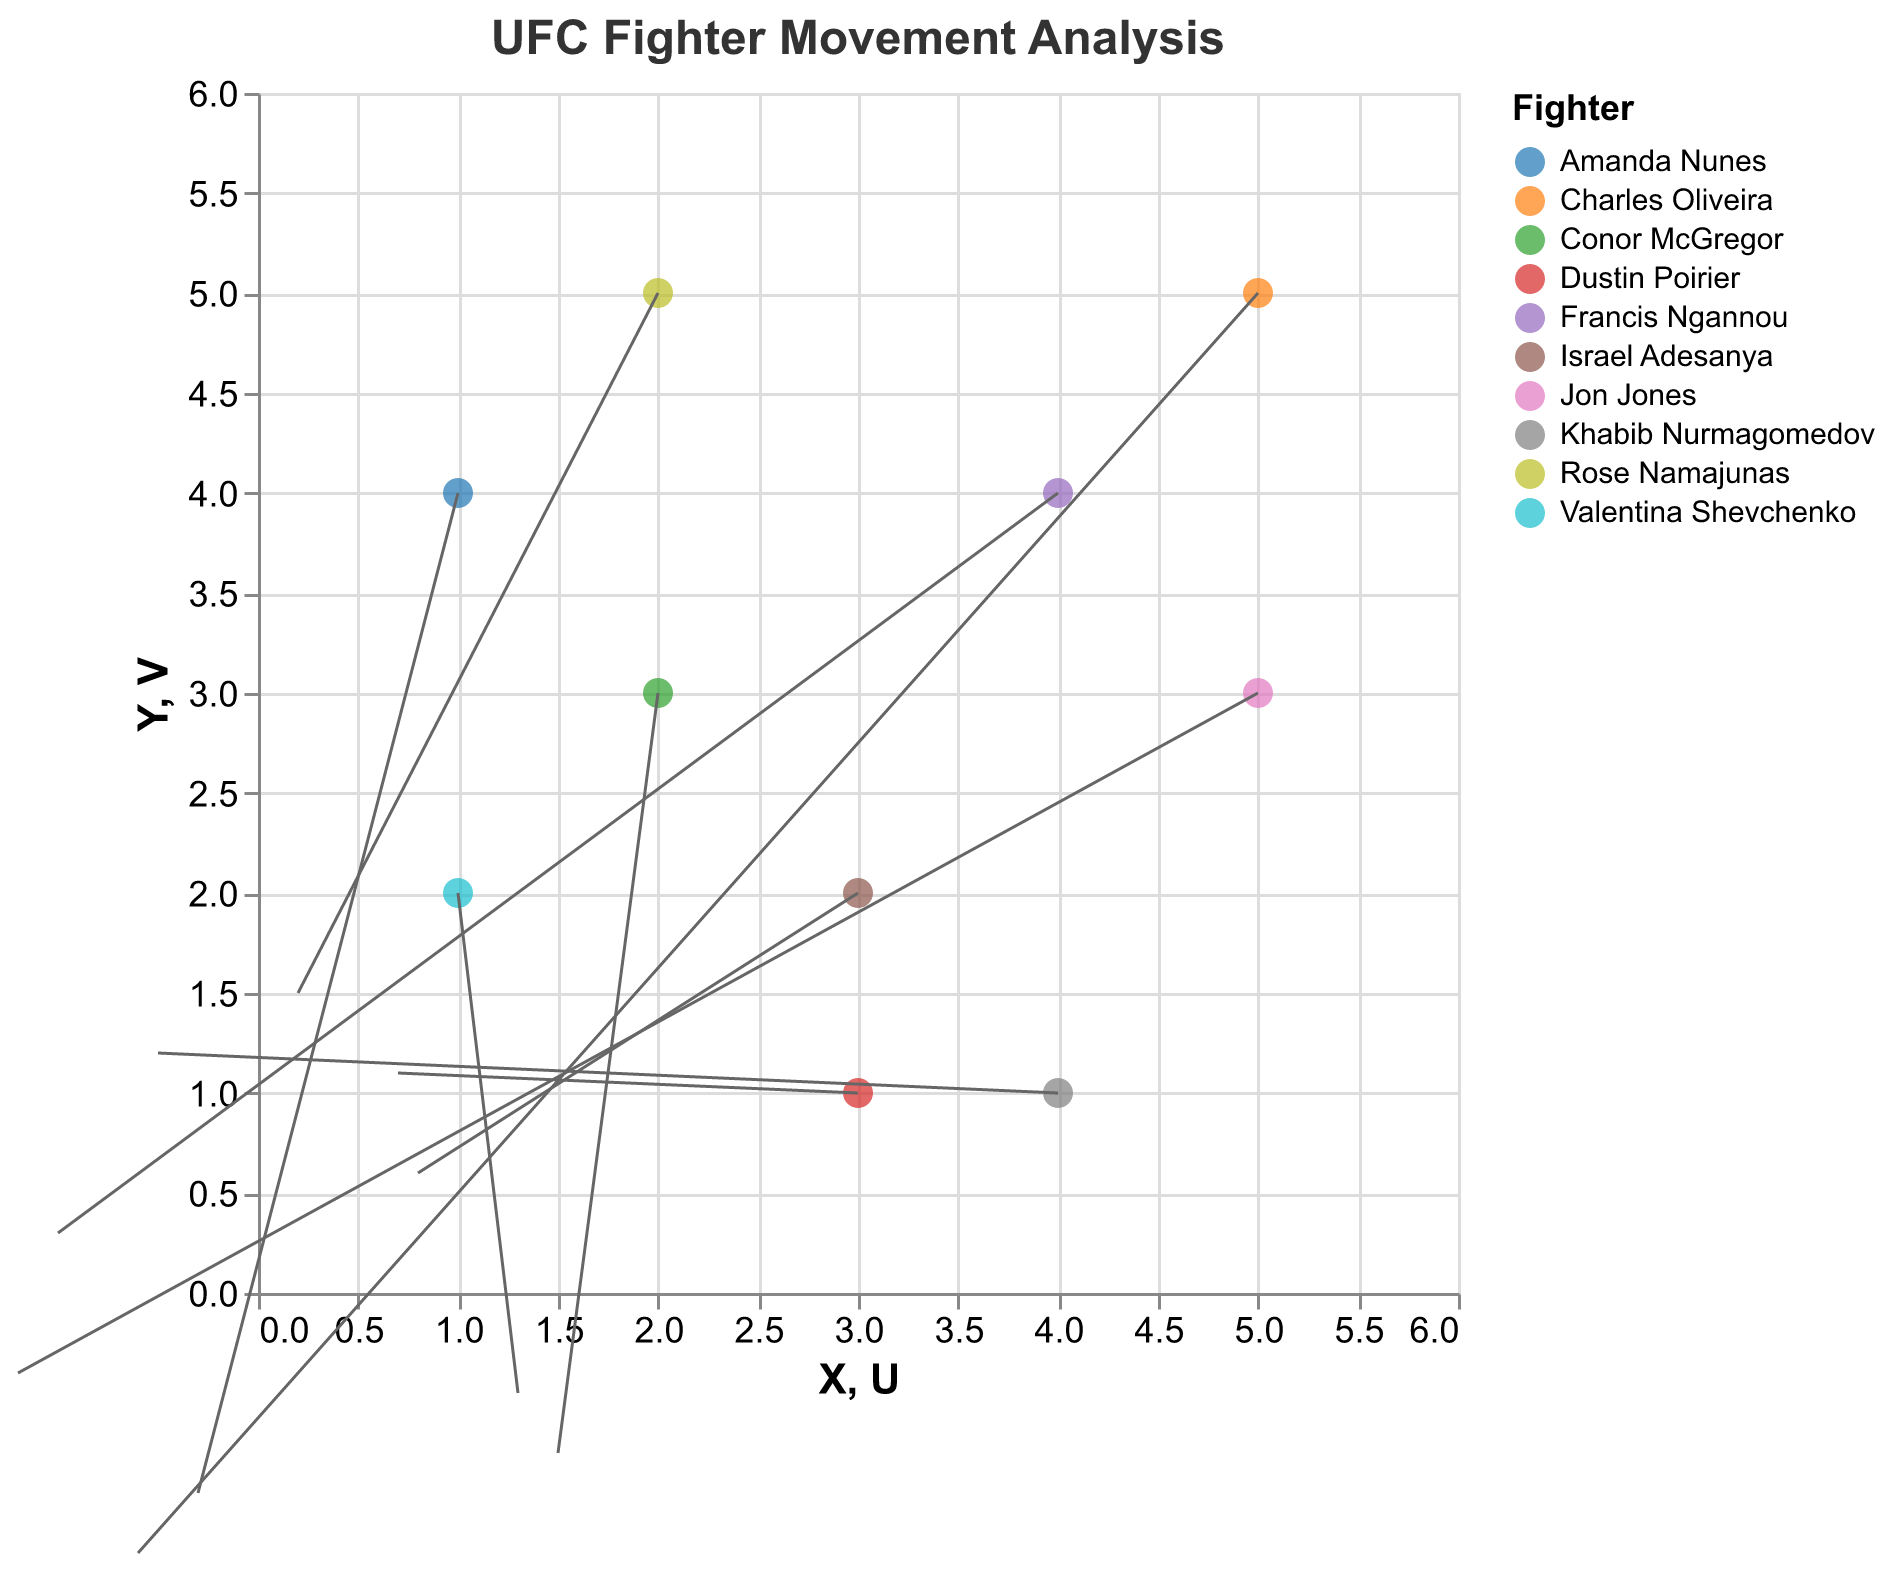How many fighters are shown in the plot? There are 10 data points in the plot, with each corresponding to a different fighter's movement in the octagon.
Answer: 10 Which fighter has the largest positive U value? The U value represents the x-component of the movement. By examining the data points, Valentina Shevchenko has the largest positive U value of 1.3.
Answer: Valentina Shevchenko Among the fighters, who moves most downward (most negative V value)? V value represents the y-component of the movement. Amanda Nunes has the most negative V value of -1.0.
Answer: Amanda Nunes Which fighter has the smallest combined movement magnitude (square root of the sum of squares of U and V)? We need to calculate the magnitude for each fighter. After calculating for all, Jon Jones has the smallest magnitude: √((-1.2)^2 + (-0.4)^2) ≈ 1.264.
Answer: Jon Jones Which fighters are moving in a generally upward direction? Fighters with V values greater than 0 are moving upward. These include Khabib Nurmagomedov, Dustin Poirier, and Rose Namajunas.
Answer: Khabib Nurmagomedov, Dustin Poirier, Rose Namajunas What is the average U value of the fighters with X coordinate less than 3? The fighters are Valentina Shevchenko, Amanda Nunes, and Conor McGregor. Their U values are 1.3, -0.3, and 1.5 respectively. The average is (1.3 + (-0.3) + 1.5)/3 = 0.833.
Answer: 0.833 How does the movement vector of Conor McGregor compare to Jon Jones? Conor McGregor's vector has U = 1.5, V = -0.8, while Jon Jones' vector has U = -1.2, V = -0.4. Conor moves more towards the right and downward, while Jon moves more left and slightly downward.
Answer: McGregor moves right and down, Jones moves left and down Which fighter's movement is most stationary (smallest combined magnitude of U and V)? We compute the magnitude for all fighters. Jon Jones has the smallest magnitude: √((-1.2)^2 + (-0.4)^2) ≈ 1.264.
Answer: Jon Jones What is the general direction of movement for Israel Adesanya? Israel Adesanya's vector is U = 0.8, V = 0.6. The positive U and V values indicate movement towards the upper right.
Answer: Upper right 